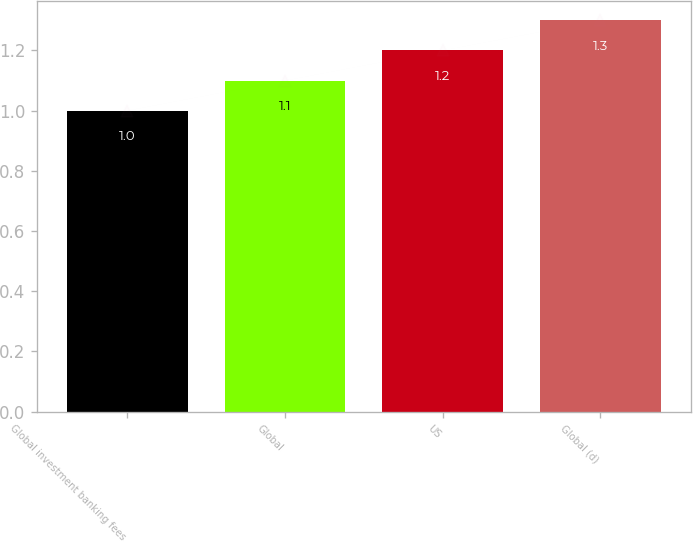<chart> <loc_0><loc_0><loc_500><loc_500><bar_chart><fcel>Global investment banking fees<fcel>Global<fcel>US<fcel>Global (d)<nl><fcel>1<fcel>1.1<fcel>1.2<fcel>1.3<nl></chart> 